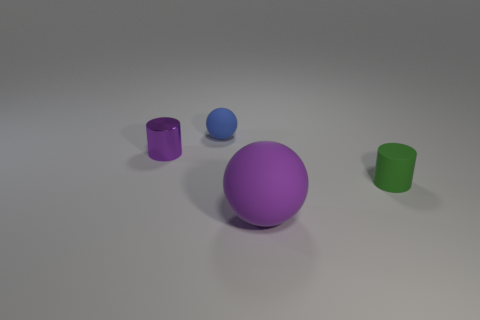Add 4 rubber things. How many objects exist? 8 Subtract all big cylinders. Subtract all small cylinders. How many objects are left? 2 Add 3 purple matte balls. How many purple matte balls are left? 4 Add 2 small purple shiny blocks. How many small purple shiny blocks exist? 2 Subtract 1 purple cylinders. How many objects are left? 3 